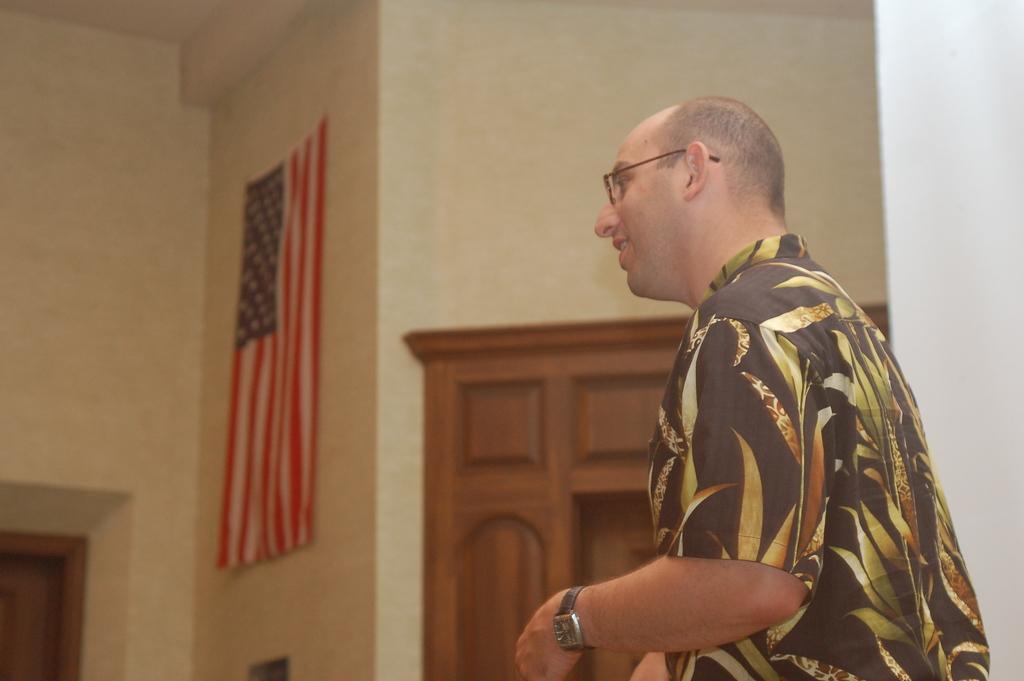In one or two sentences, can you explain what this image depicts? In the center of the image there is a person standing and wearing a glasses. In the background we can see flag, wall and door. 